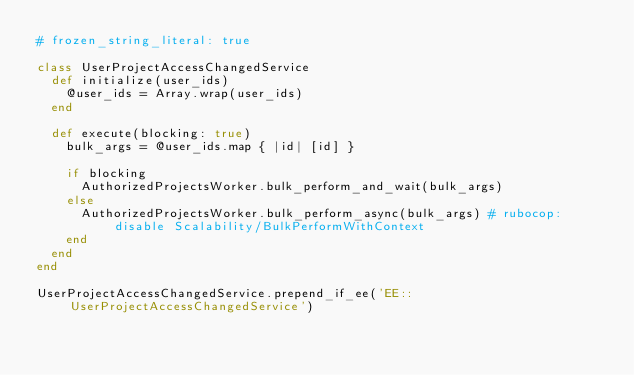Convert code to text. <code><loc_0><loc_0><loc_500><loc_500><_Ruby_># frozen_string_literal: true

class UserProjectAccessChangedService
  def initialize(user_ids)
    @user_ids = Array.wrap(user_ids)
  end

  def execute(blocking: true)
    bulk_args = @user_ids.map { |id| [id] }

    if blocking
      AuthorizedProjectsWorker.bulk_perform_and_wait(bulk_args)
    else
      AuthorizedProjectsWorker.bulk_perform_async(bulk_args) # rubocop:disable Scalability/BulkPerformWithContext
    end
  end
end

UserProjectAccessChangedService.prepend_if_ee('EE::UserProjectAccessChangedService')
</code> 